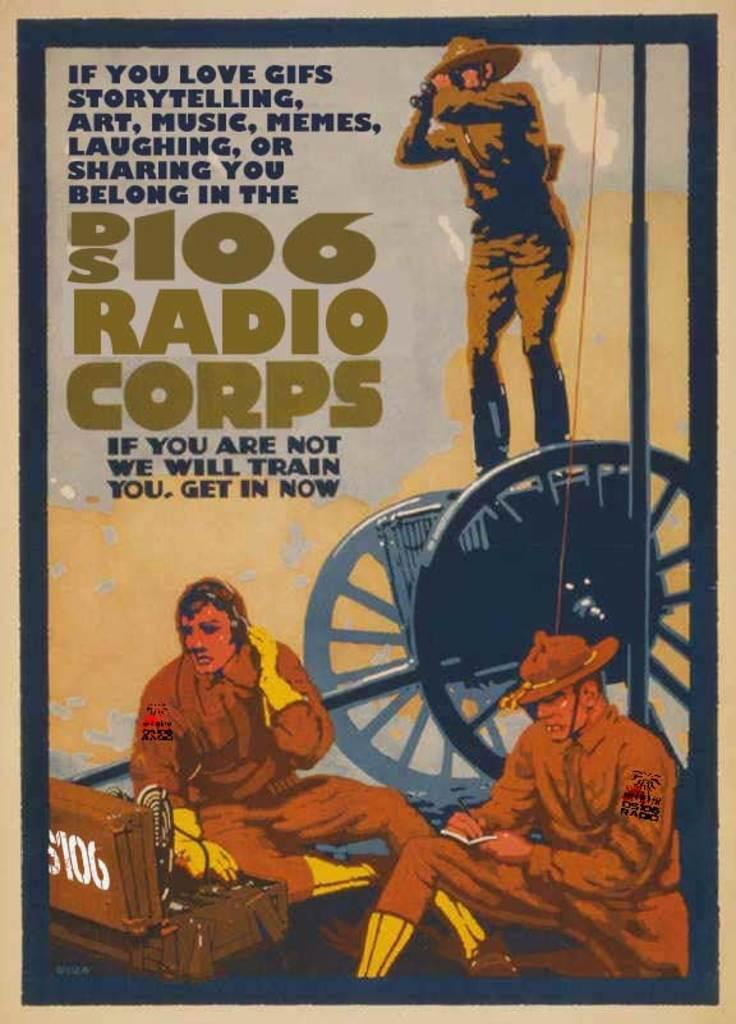Provide a one-sentence caption for the provided image. Radio corps sign for people who love art, music,. 